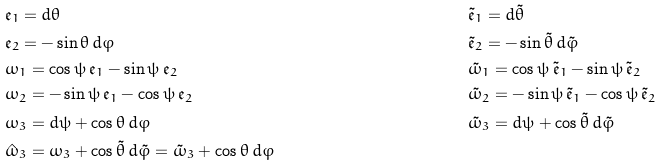Convert formula to latex. <formula><loc_0><loc_0><loc_500><loc_500>& \mathfrak { e } _ { 1 } = d \theta & & \tilde { \mathfrak { e } } _ { 1 } = d \tilde { \theta } \\ & \mathfrak { e } _ { 2 } = - \sin \theta \, d \varphi & & \tilde { \mathfrak { e } } _ { 2 } = - \sin \tilde { \theta } \, d \tilde { \varphi } \\ & \omega _ { 1 } = \cos \psi \, \mathfrak { e } _ { 1 } - \sin \psi \, \mathfrak { e } _ { 2 } & & \tilde { \omega } _ { 1 } = \cos \psi \, \tilde { \mathfrak { e } } _ { 1 } - \sin \psi \, \tilde { \mathfrak { e } } _ { 2 } \\ & \omega _ { 2 } = - \sin \psi \, \mathfrak { e } _ { 1 } - \cos \psi \, \mathfrak { e } _ { 2 } & & \tilde { \omega } _ { 2 } = - \sin \psi \, \tilde { \mathfrak { e } } _ { 1 } - \cos \psi \, \tilde { \mathfrak { e } } _ { 2 } \\ & \omega _ { 3 } = d \psi + \cos \theta \, d \varphi & & \tilde { \omega } _ { 3 } = d \psi + \cos \tilde { \theta } \, d \tilde { \varphi } \\ & \hat { \omega } _ { 3 } = \omega _ { 3 } + \cos \tilde { \theta } \, d \tilde { \varphi } = \tilde { \omega } _ { 3 } + \cos \theta \, d \varphi</formula> 